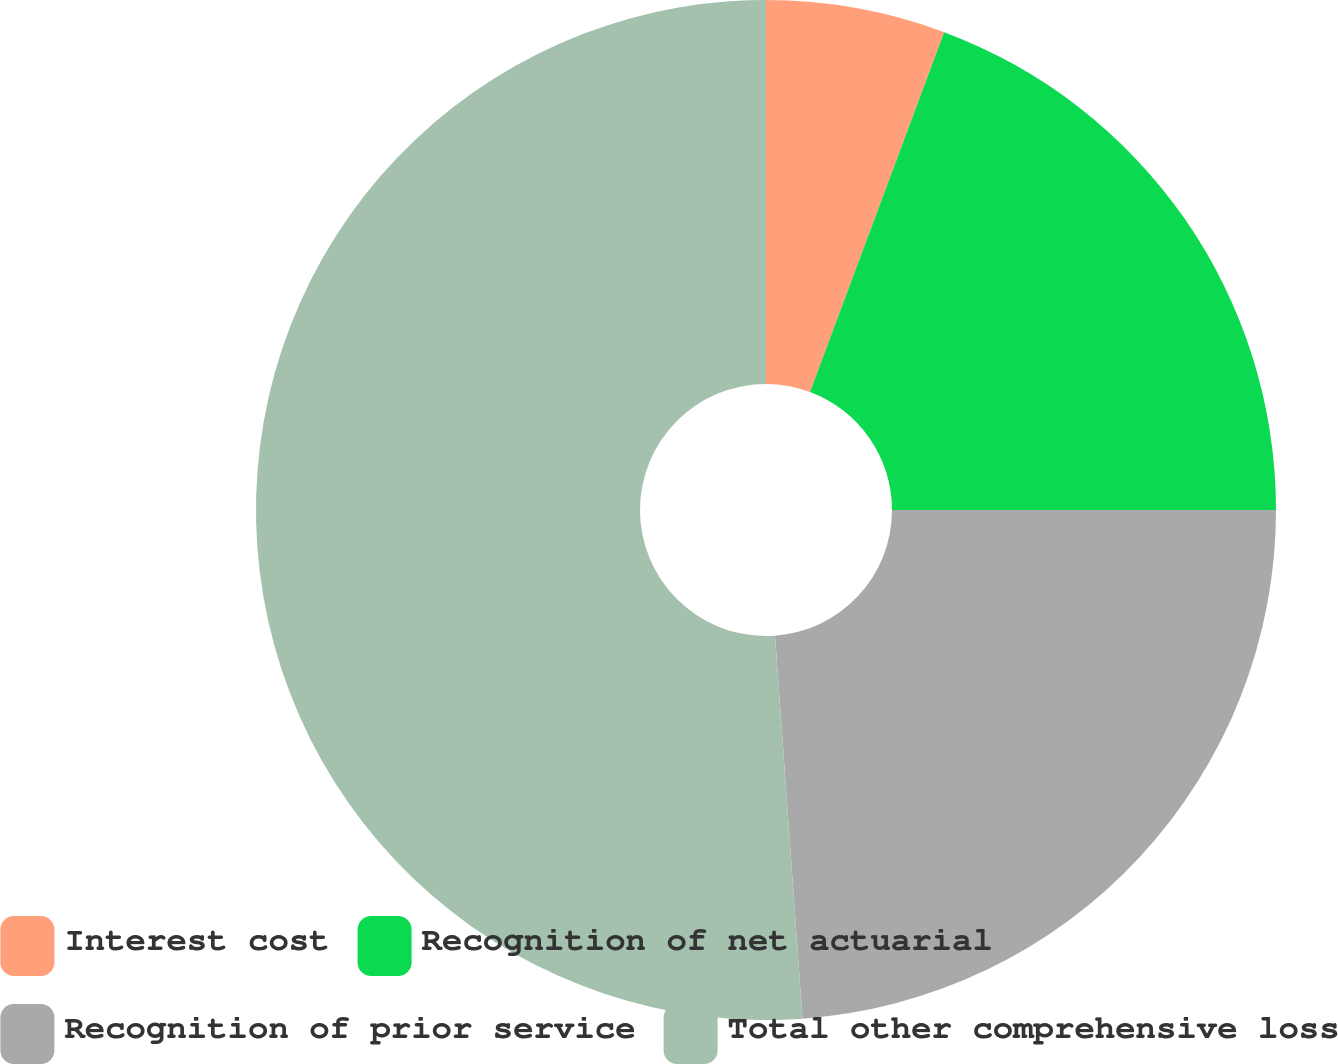Convert chart to OTSL. <chart><loc_0><loc_0><loc_500><loc_500><pie_chart><fcel>Interest cost<fcel>Recognition of net actuarial<fcel>Recognition of prior service<fcel>Total other comprehensive loss<nl><fcel>5.68%<fcel>19.32%<fcel>23.86%<fcel>51.14%<nl></chart> 